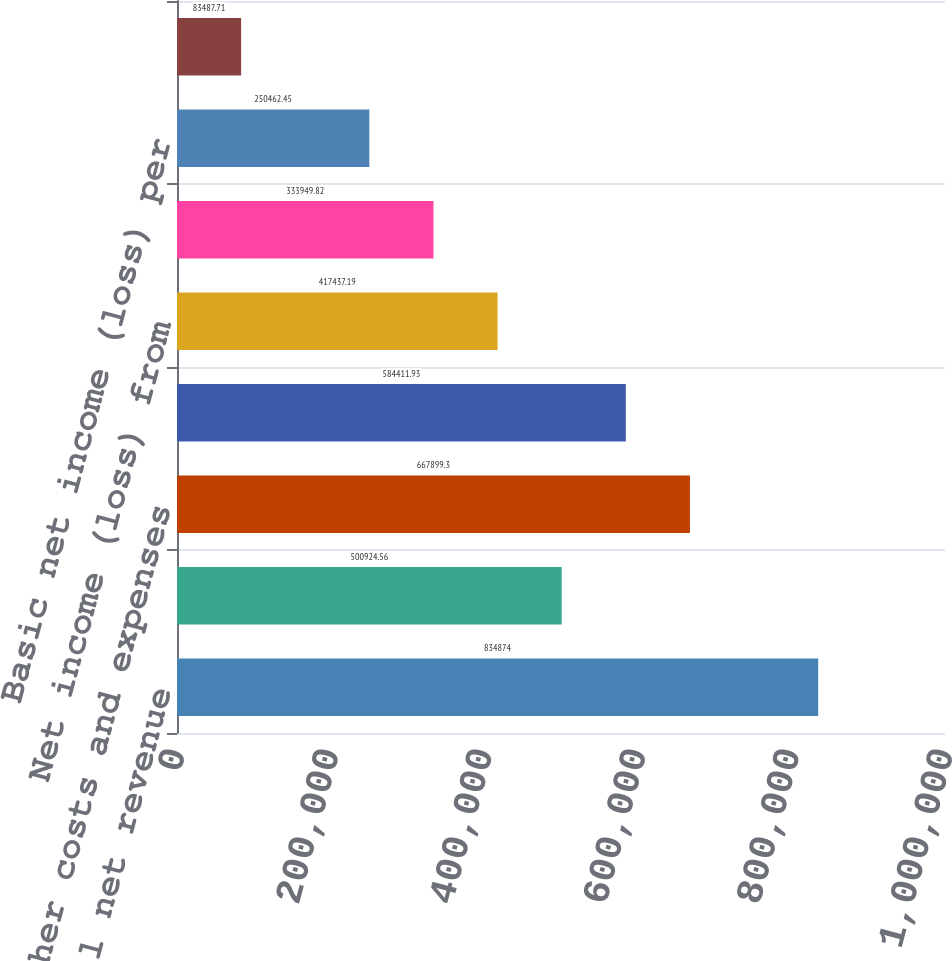Convert chart. <chart><loc_0><loc_0><loc_500><loc_500><bar_chart><fcel>Total net revenue<fcel>Cost of revenue<fcel>All other costs and expenses<fcel>Operating income (loss) from<fcel>Net income (loss) from<fcel>Net income (loss)<fcel>Basic net income (loss) per<fcel>Diluted net income (loss) per<nl><fcel>834874<fcel>500925<fcel>667899<fcel>584412<fcel>417437<fcel>333950<fcel>250462<fcel>83487.7<nl></chart> 